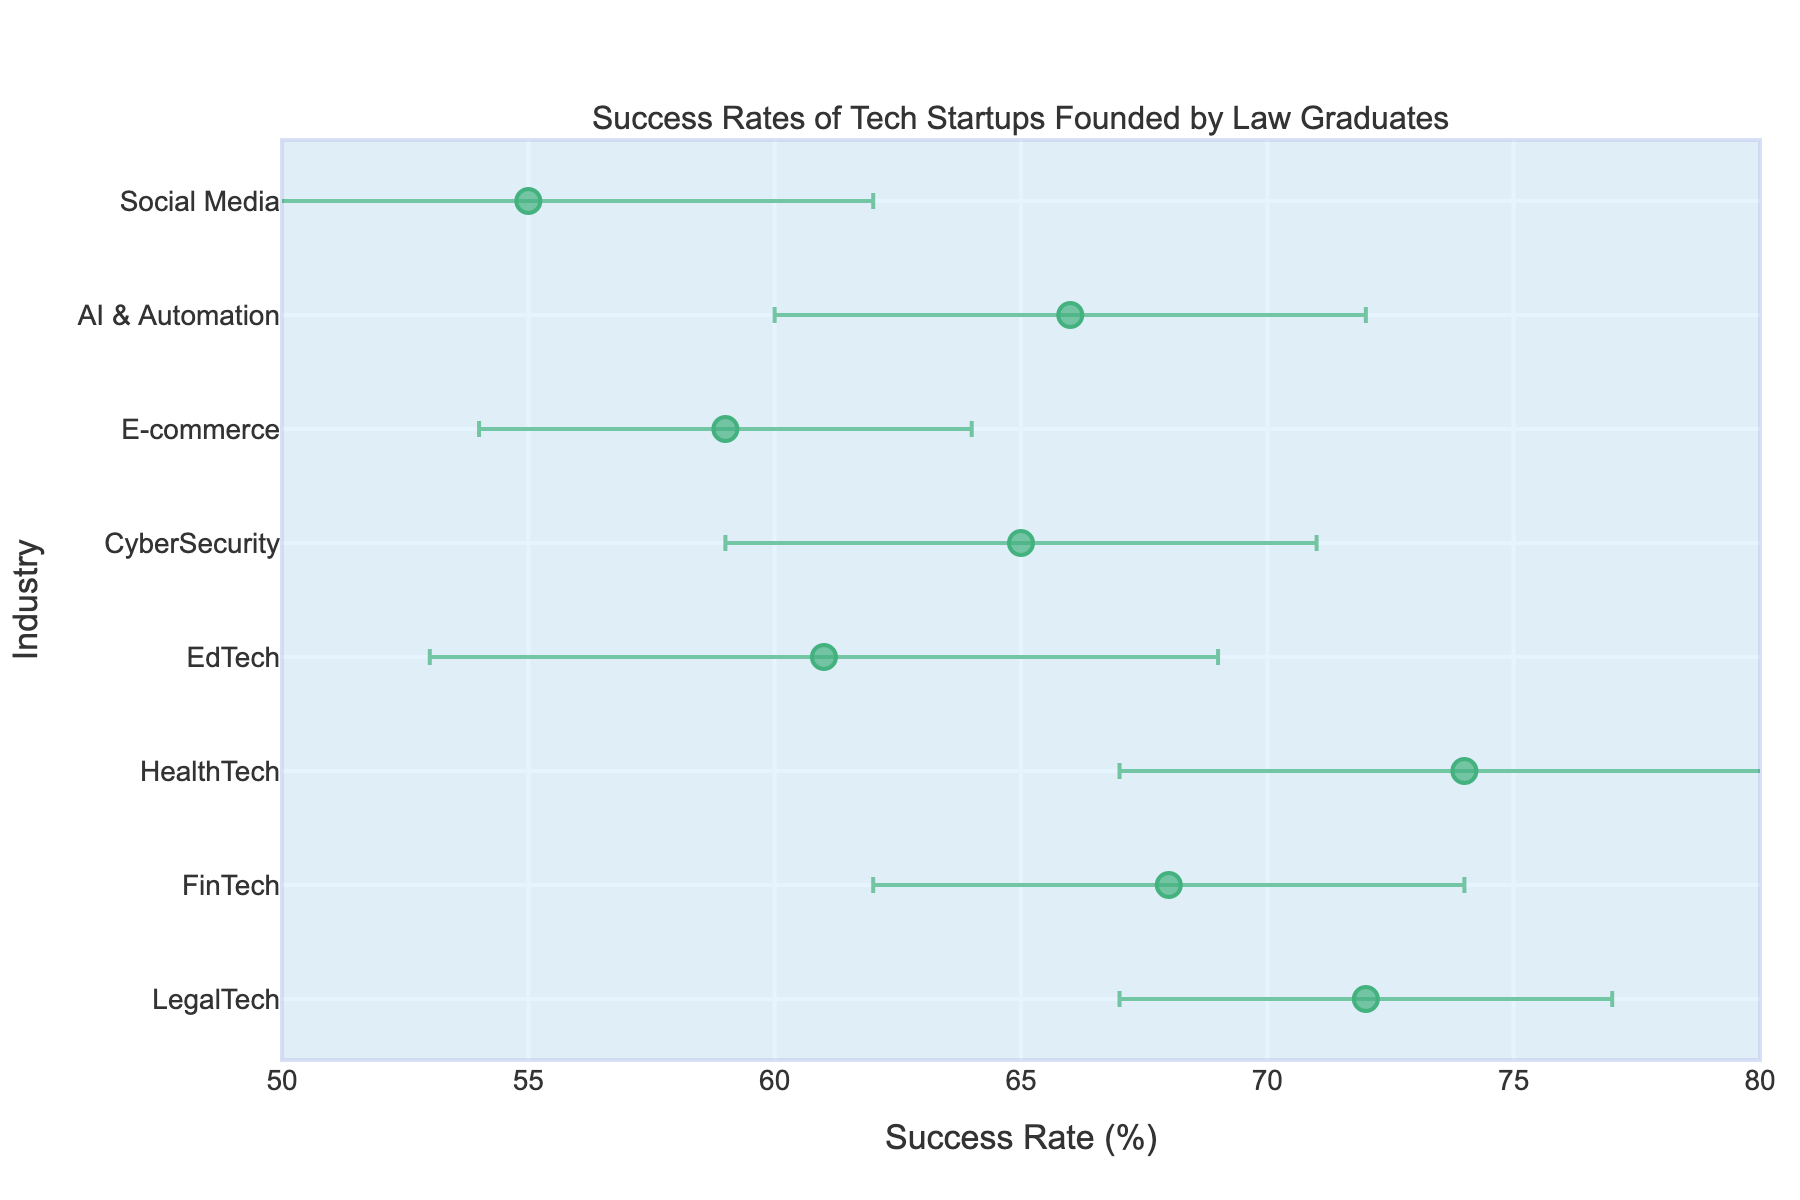What is the title of the plot? The plot title is usually located at the top of the figure. Here, the title clearly states that the visualization is about the success rates of tech startups founded by law graduates.
Answer: Success Rates of Tech Startups Founded by Law Graduates What industry has the highest success rate? To determine this, look at the position of the markers along the x-axis (Success Rate) and find the one furthest to the right. According to the plot, the highest success rate is in the HealthTech industry.
Answer: HealthTech What is the success rate of E-commerce startups, and what is its error margin? Locate the marker representing E-commerce along the y-axis and read the success rate value on the x-axis and its corresponding error bar. The success rate for E-commerce is 59%, and the error margin is 5%.
Answer: 59%, 5% Which industry has the lowest success rate, and what is this rate? Identify the marker positioned furthest to the left along the x-axis, which represents the industry with the lowest success rate. The industry with the lowest success rate is Social Media, with a rate of 55%.
Answer: Social Media, 55% How many industries have success rates that fall within the range 60% to 70%? Count the markers whose x-axis values (Success Rates) fall between 60% and 70%. There are four industries: FinTech, EdTech, CyberSecurity, and AI & Automation.
Answer: 4 What is the difference in success rate between the highest and lowest performing industries? Subtract the lowest success rate (Social Media at 55%) from the highest success rate (HealthTech at 74%). 74 - 55 equals 19.
Answer: 19% Which industry has the widest error margin, and what is this margin? Identify the error margins by checking the distance the error bars extend from the marker. The industry with the widest margin is HealthTech, with an error of 7%.
Answer: HealthTech, 7% Is there any industry with a success rate exactly at 70%? Check the x-axis values of all markers to see if any marker aligns with the 70% mark. None of the industries have a success rate of exactly 70%.
Answer: No How does the success rate of LegalTech compare to that of EdTech? Compare the positions of the markers for LegalTech and EdTech along the x-axis. LegalTech has a success rate of 72%, while EdTech has 61%. Thus, LegalTech has a higher success rate.
Answer: LegalTech is higher 